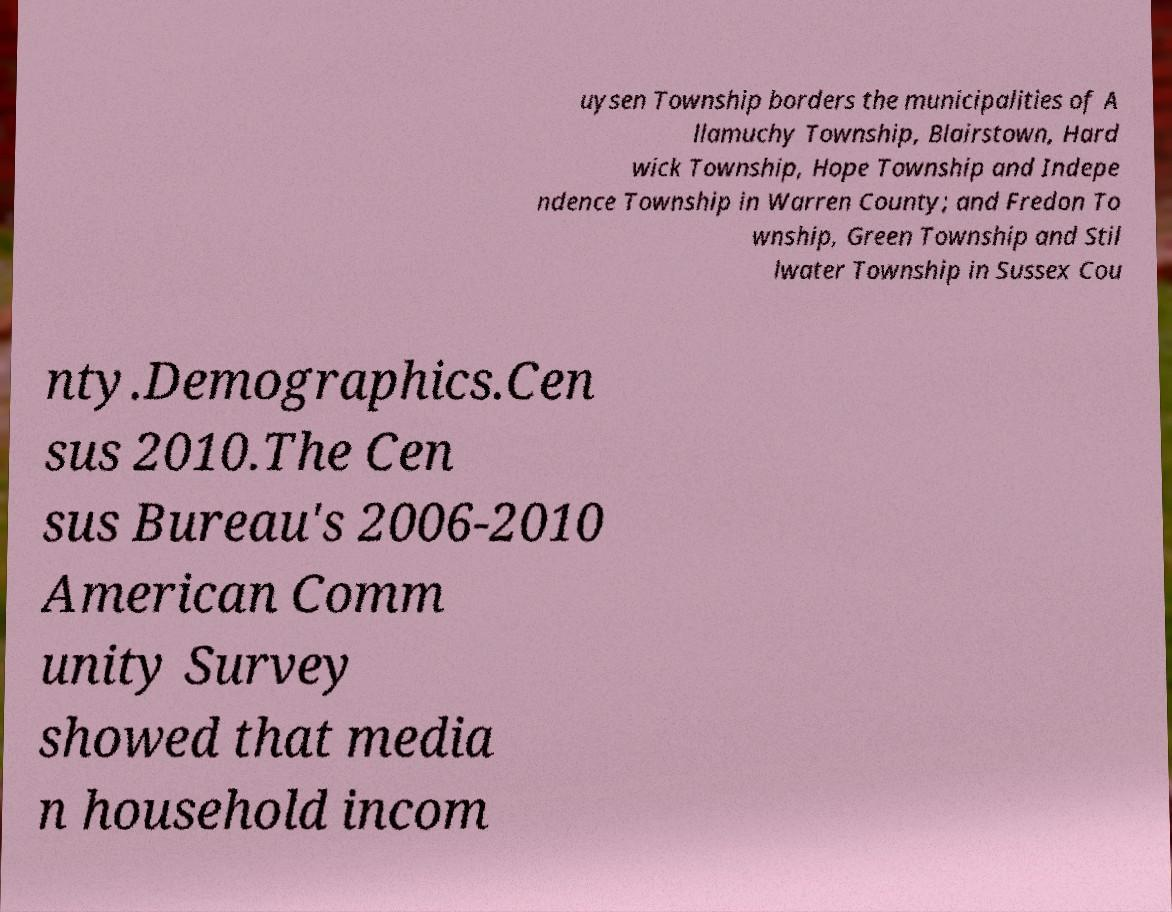What messages or text are displayed in this image? I need them in a readable, typed format. uysen Township borders the municipalities of A llamuchy Township, Blairstown, Hard wick Township, Hope Township and Indepe ndence Township in Warren County; and Fredon To wnship, Green Township and Stil lwater Township in Sussex Cou nty.Demographics.Cen sus 2010.The Cen sus Bureau's 2006-2010 American Comm unity Survey showed that media n household incom 